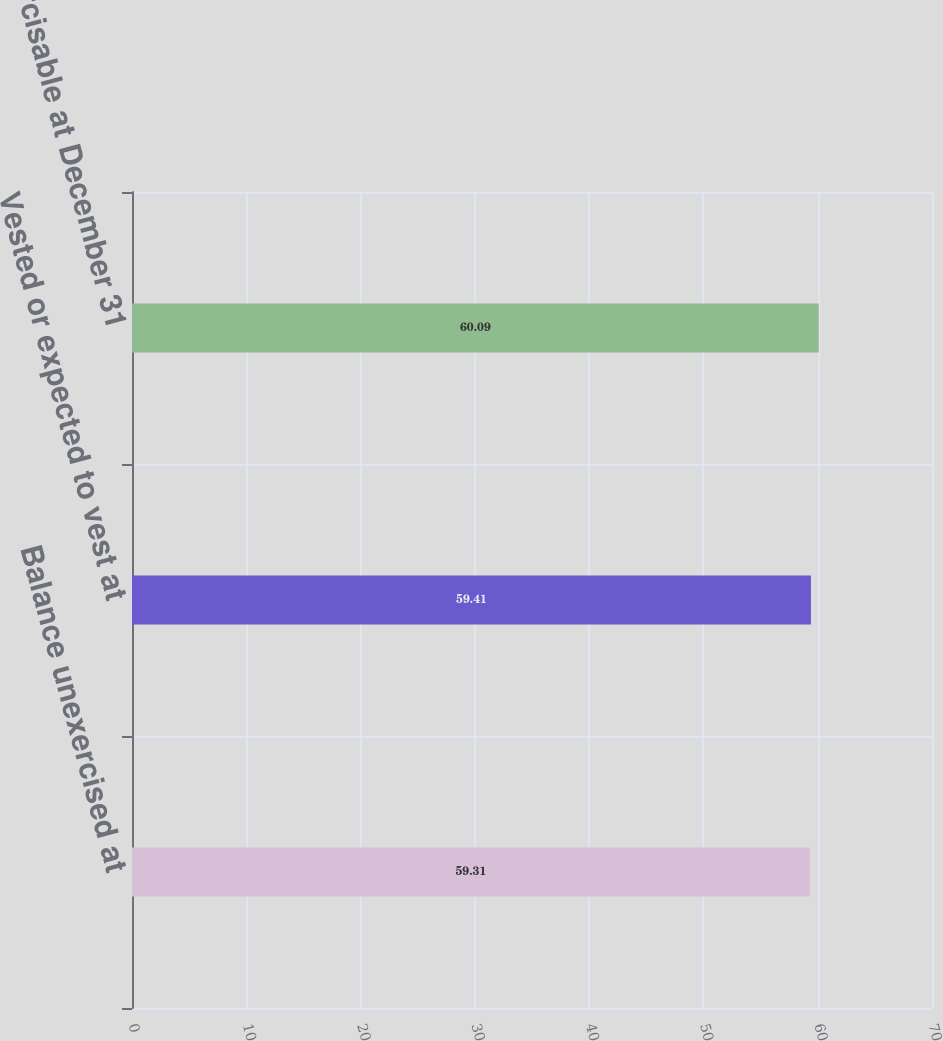<chart> <loc_0><loc_0><loc_500><loc_500><bar_chart><fcel>Balance unexercised at<fcel>Vested or expected to vest at<fcel>Exercisable at December 31<nl><fcel>59.31<fcel>59.41<fcel>60.09<nl></chart> 